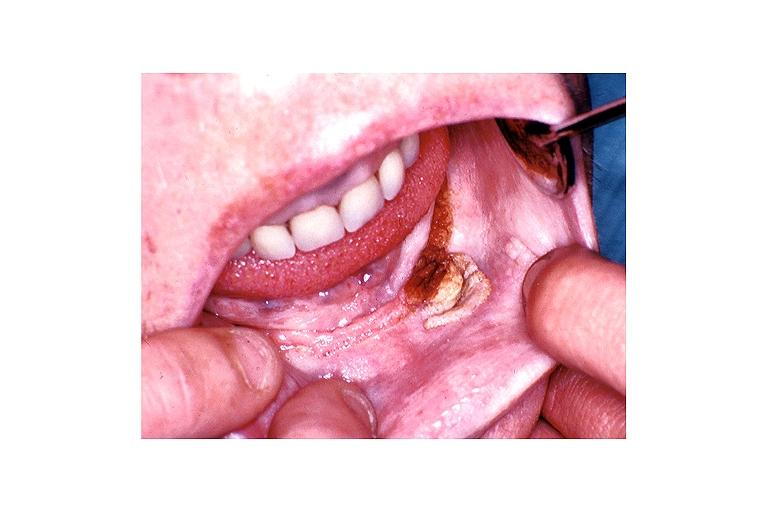what does this image show?
Answer the question using a single word or phrase. Verruca vulgaris 